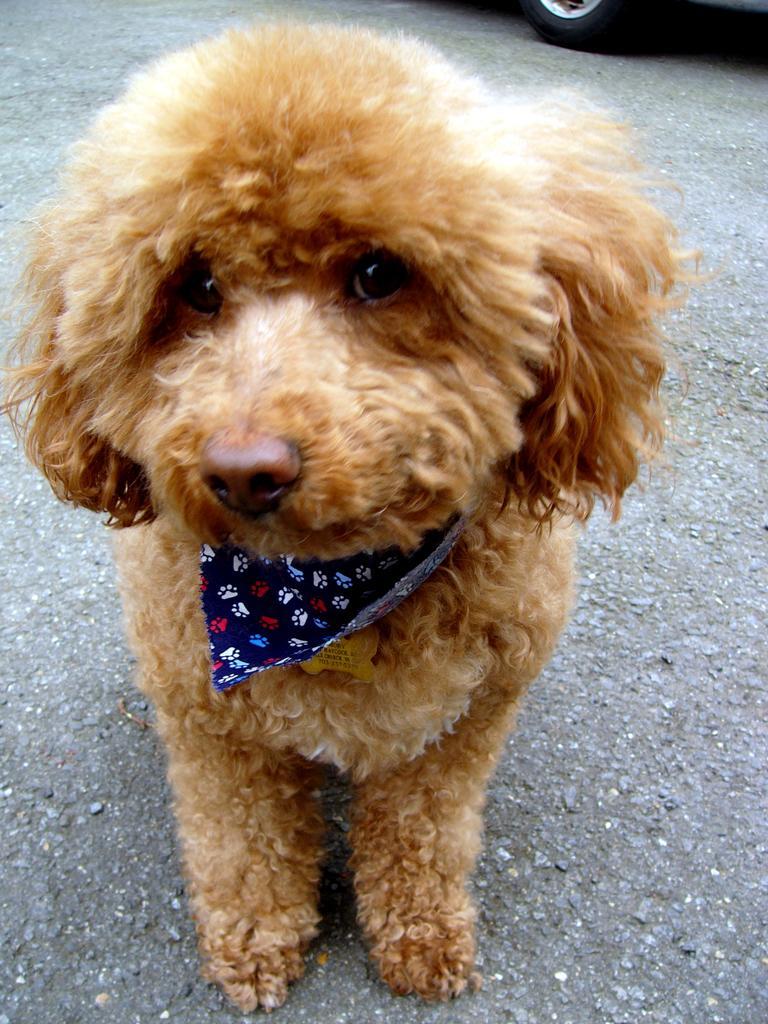Describe this image in one or two sentences. In this picture I can see a dog is standing on the ground. The dog is wearing an object. In the background I can see a vehicle. 